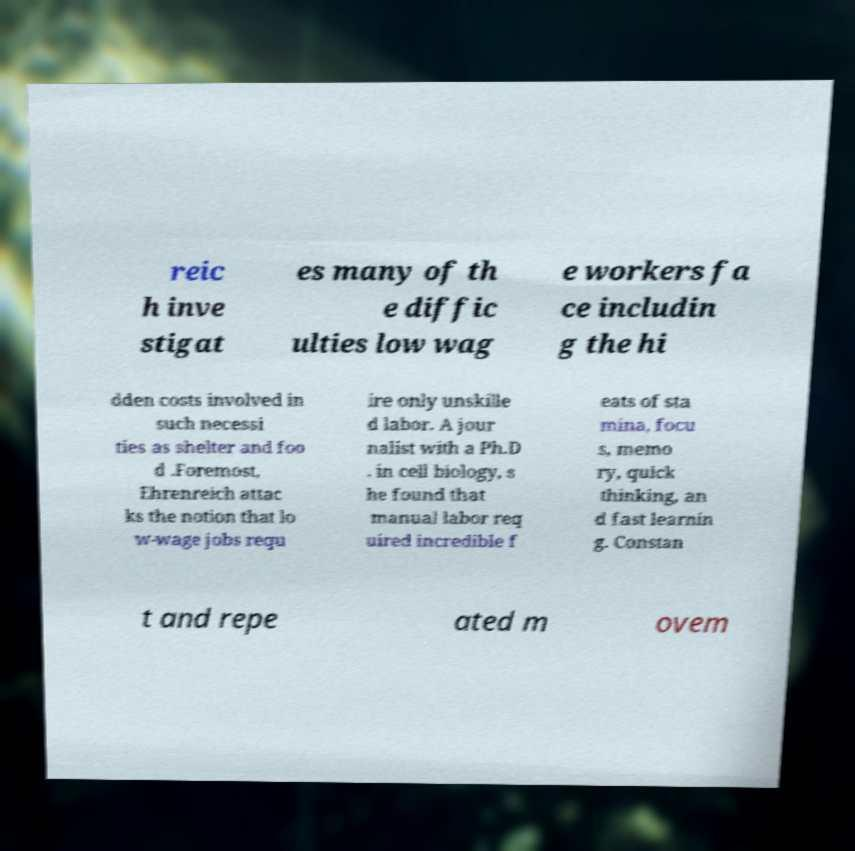Can you read and provide the text displayed in the image?This photo seems to have some interesting text. Can you extract and type it out for me? reic h inve stigat es many of th e diffic ulties low wag e workers fa ce includin g the hi dden costs involved in such necessi ties as shelter and foo d .Foremost, Ehrenreich attac ks the notion that lo w-wage jobs requ ire only unskille d labor. A jour nalist with a Ph.D . in cell biology, s he found that manual labor req uired incredible f eats of sta mina, focu s, memo ry, quick thinking, an d fast learnin g. Constan t and repe ated m ovem 